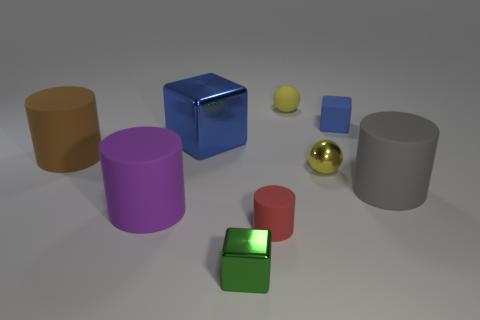Do the big metal object and the tiny matte block have the same color?
Keep it short and to the point. Yes. What shape is the other object that is the same color as the large metal thing?
Make the answer very short. Cube. What is the material of the blue object to the right of the tiny shiny block that is left of the tiny yellow matte thing?
Ensure brevity in your answer.  Rubber. Is the size of the gray object the same as the yellow rubber sphere?
Provide a succinct answer. No. Are there any big rubber objects behind the small metal thing that is to the right of the small green metallic cube?
Give a very brief answer. Yes. Is there a brown thing?
Keep it short and to the point. Yes. How many red cylinders are the same size as the yellow rubber ball?
Offer a terse response. 1. What number of tiny yellow things are both in front of the large block and behind the tiny blue rubber object?
Offer a very short reply. 0. Do the shiny block that is behind the brown thing and the small yellow rubber object have the same size?
Your response must be concise. No. Is there a tiny object that has the same color as the large shiny block?
Your response must be concise. Yes. 